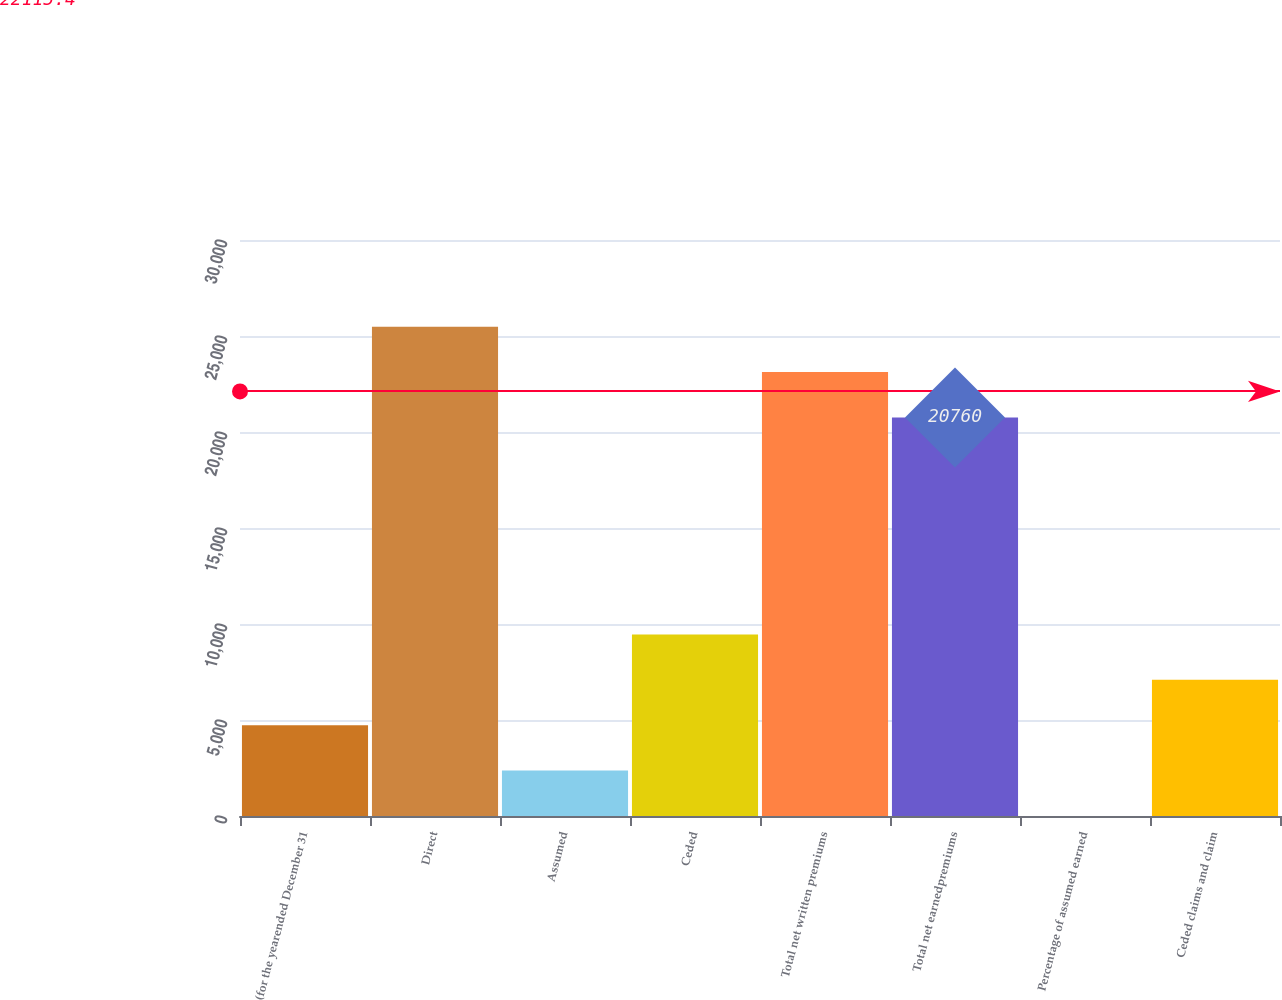<chart> <loc_0><loc_0><loc_500><loc_500><bar_chart><fcel>(for the yearended December 31<fcel>Direct<fcel>Assumed<fcel>Ceded<fcel>Total net written premiums<fcel>Total net earnedpremiums<fcel>Percentage of assumed earned<fcel>Ceded claims and claim<nl><fcel>4728.84<fcel>25486.5<fcel>2365.57<fcel>9455.38<fcel>23123.3<fcel>20760<fcel>2.3<fcel>7092.11<nl></chart> 